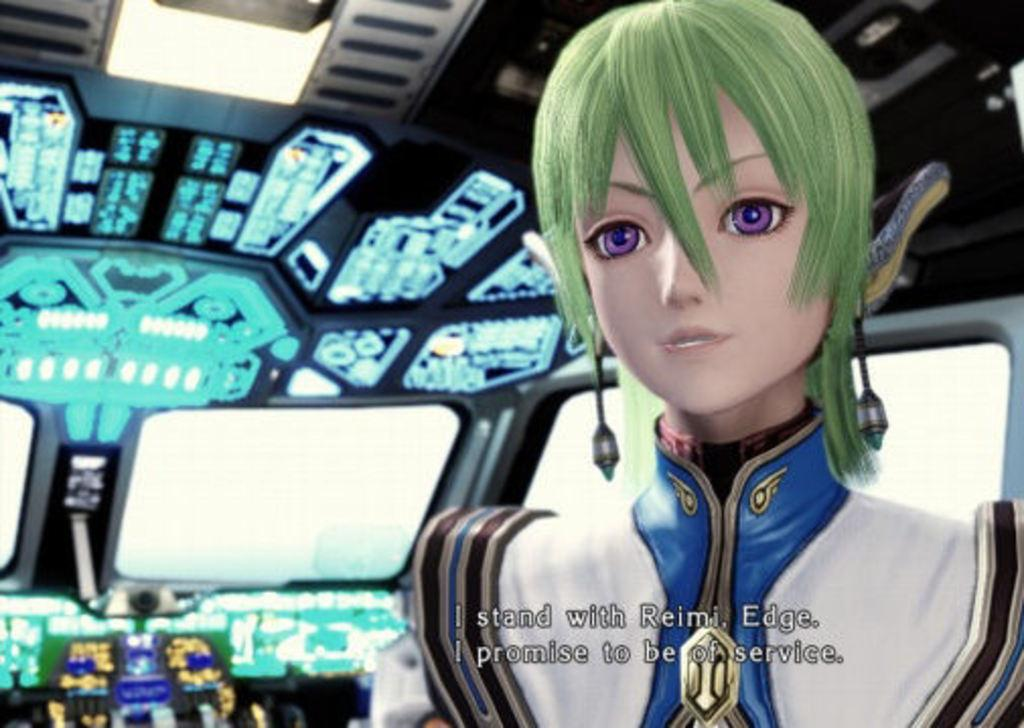Provide a one-sentence caption for the provided image. a cartoon person who refers to Reimi is on a ship of some sort. 